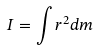<formula> <loc_0><loc_0><loc_500><loc_500>I = \int r ^ { 2 } d m</formula> 